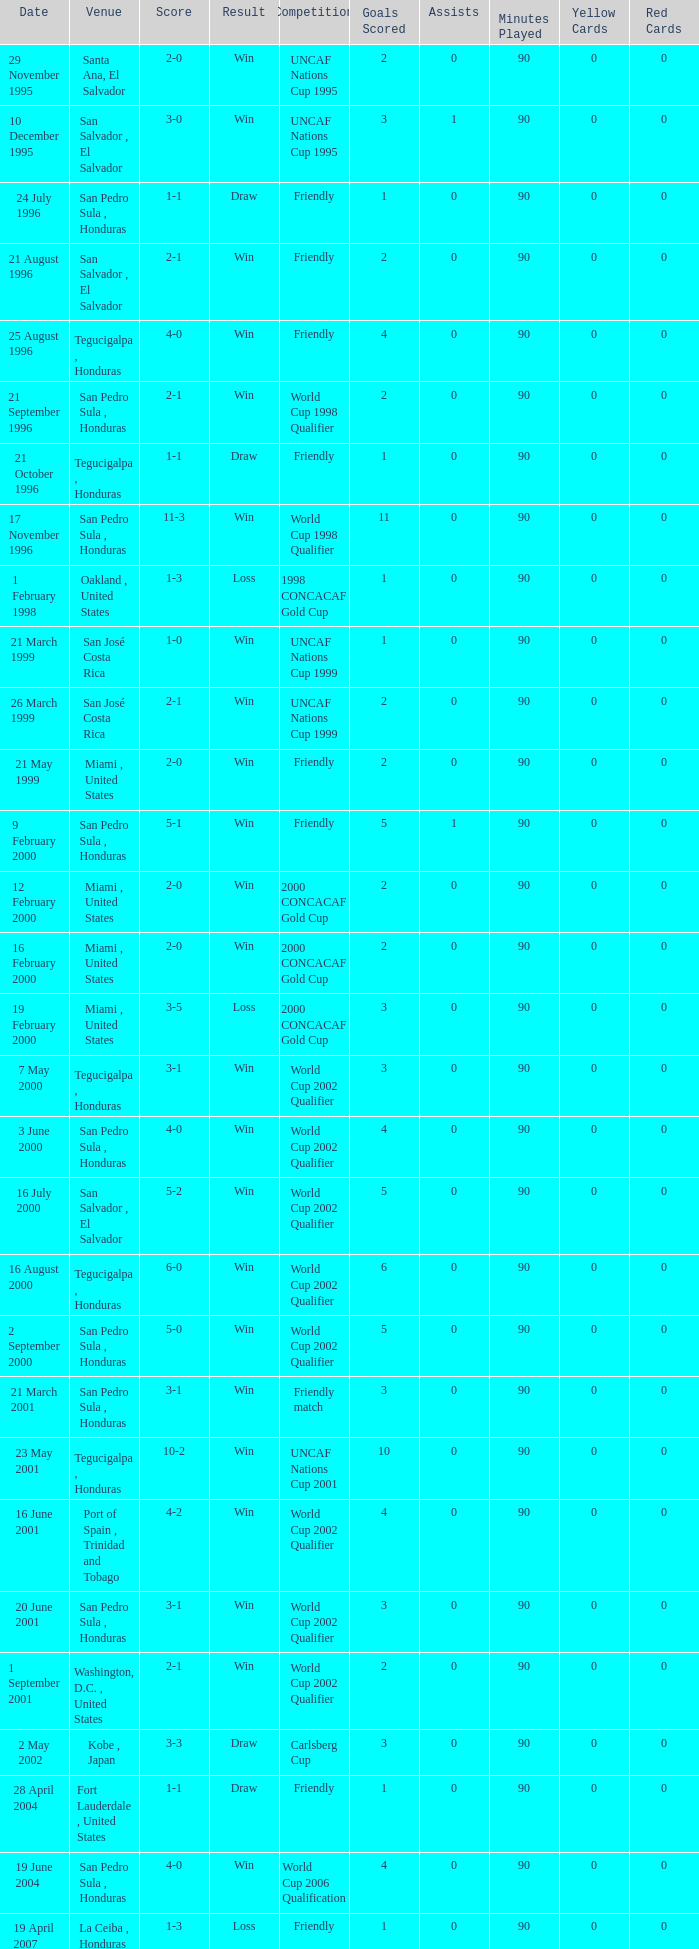What is the venue for the friendly competition and score of 4-0? Tegucigalpa , Honduras. 